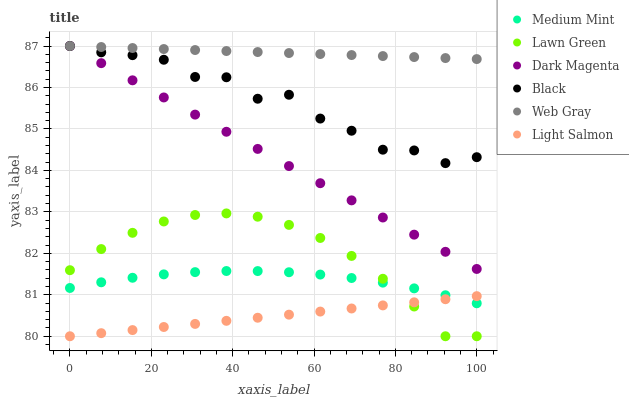Does Light Salmon have the minimum area under the curve?
Answer yes or no. Yes. Does Web Gray have the maximum area under the curve?
Answer yes or no. Yes. Does Lawn Green have the minimum area under the curve?
Answer yes or no. No. Does Lawn Green have the maximum area under the curve?
Answer yes or no. No. Is Dark Magenta the smoothest?
Answer yes or no. Yes. Is Black the roughest?
Answer yes or no. Yes. Is Lawn Green the smoothest?
Answer yes or no. No. Is Lawn Green the roughest?
Answer yes or no. No. Does Lawn Green have the lowest value?
Answer yes or no. Yes. Does Web Gray have the lowest value?
Answer yes or no. No. Does Black have the highest value?
Answer yes or no. Yes. Does Lawn Green have the highest value?
Answer yes or no. No. Is Lawn Green less than Dark Magenta?
Answer yes or no. Yes. Is Dark Magenta greater than Light Salmon?
Answer yes or no. Yes. Does Light Salmon intersect Lawn Green?
Answer yes or no. Yes. Is Light Salmon less than Lawn Green?
Answer yes or no. No. Is Light Salmon greater than Lawn Green?
Answer yes or no. No. Does Lawn Green intersect Dark Magenta?
Answer yes or no. No. 